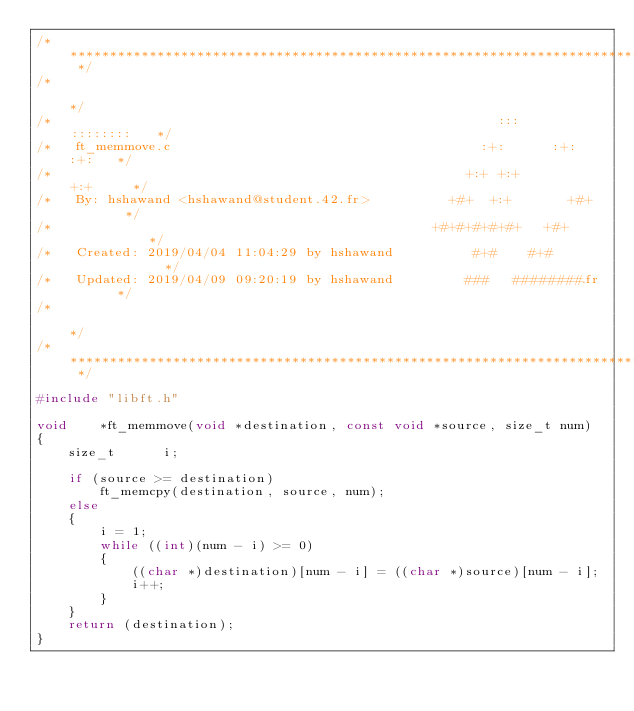<code> <loc_0><loc_0><loc_500><loc_500><_C_>/* ************************************************************************** */
/*                                                                            */
/*                                                        :::      ::::::::   */
/*   ft_memmove.c                                       :+:      :+:    :+:   */
/*                                                    +:+ +:+         +:+     */
/*   By: hshawand <hshawand@student.42.fr>          +#+  +:+       +#+        */
/*                                                +#+#+#+#+#+   +#+           */
/*   Created: 2019/04/04 11:04:29 by hshawand          #+#    #+#             */
/*   Updated: 2019/04/09 09:20:19 by hshawand         ###   ########.fr       */
/*                                                                            */
/* ************************************************************************** */

#include "libft.h"

void	*ft_memmove(void *destination, const void *source, size_t num)
{
	size_t		i;

	if (source >= destination)
		ft_memcpy(destination, source, num);
	else
	{
		i = 1;
		while ((int)(num - i) >= 0)
		{
			((char *)destination)[num - i] = ((char *)source)[num - i];
			i++;
		}
	}
	return (destination);
}
</code> 